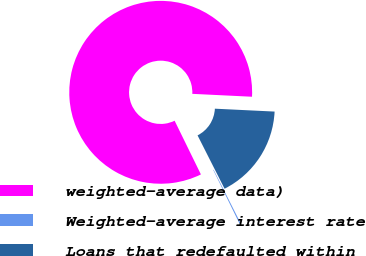Convert chart to OTSL. <chart><loc_0><loc_0><loc_500><loc_500><pie_chart><fcel>weighted-average data)<fcel>Weighted-average interest rate<fcel>Loans that redefaulted within<nl><fcel>83.01%<fcel>0.21%<fcel>16.77%<nl></chart> 